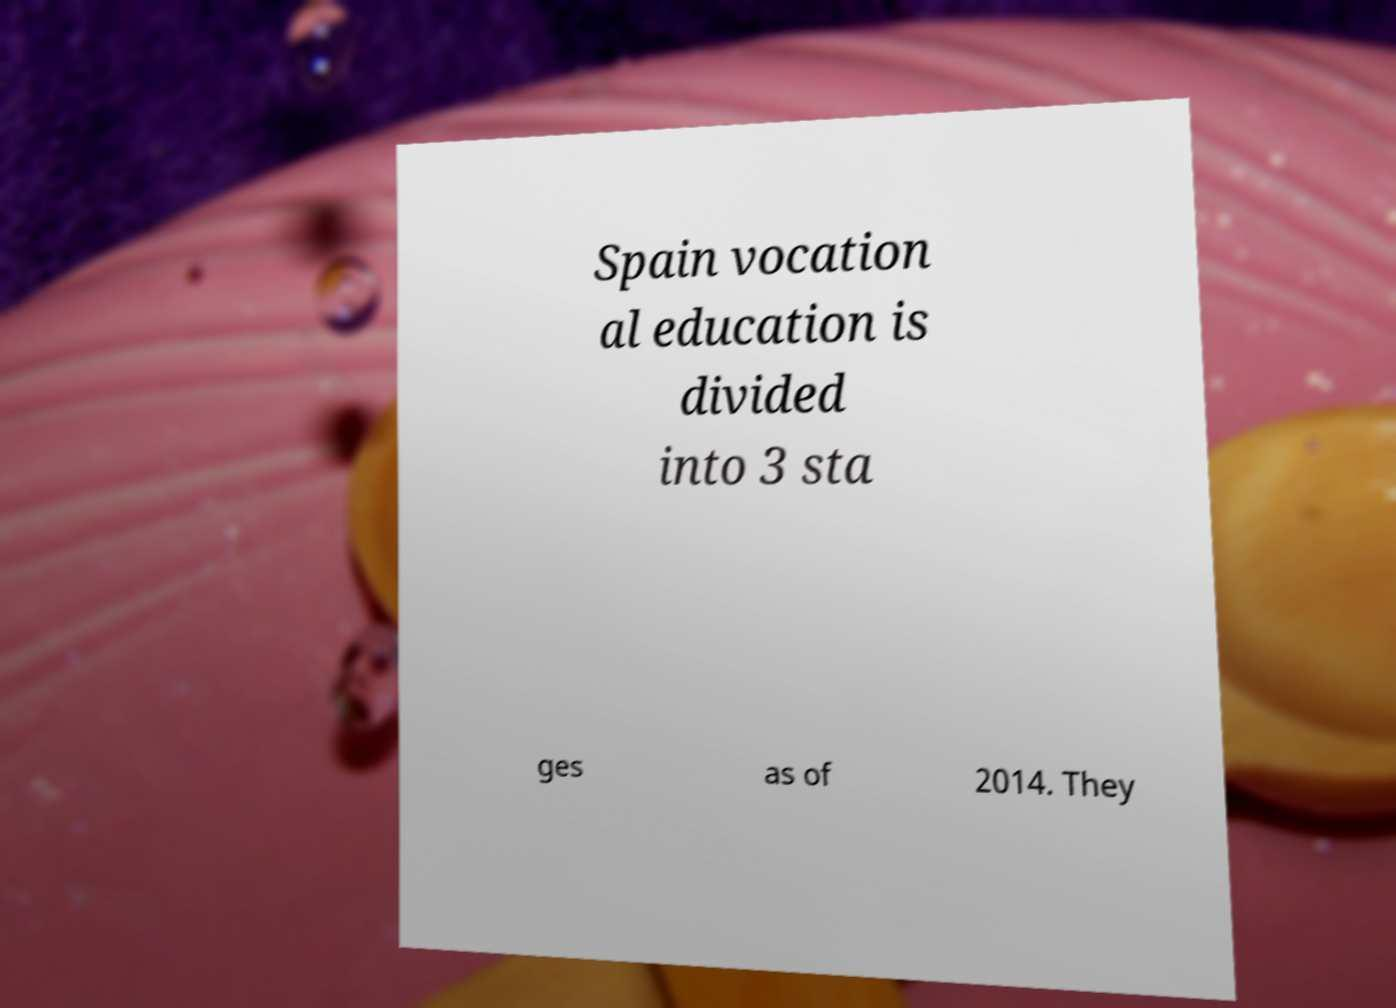I need the written content from this picture converted into text. Can you do that? Spain vocation al education is divided into 3 sta ges as of 2014. They 